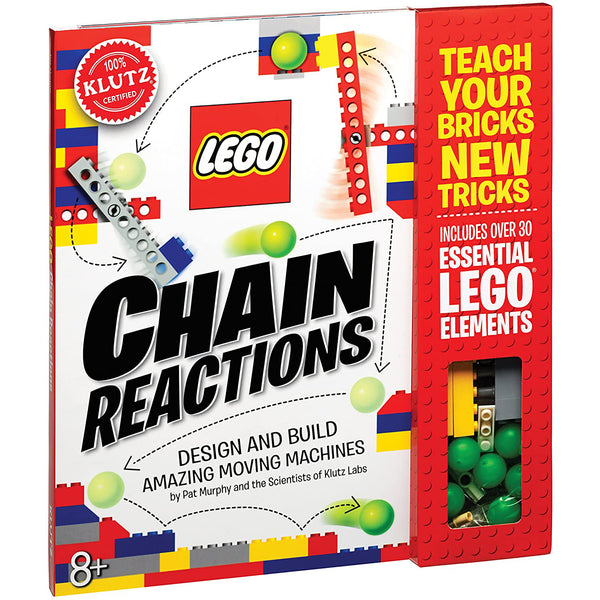Considering the visible LEGO elements through the cut-out window on the cover, what types of simple machines can potentially be built with them, and how might they demonstrate fundamental principles of physics? The visible LEGO elements displayed through the cut-out window, including gears, balls, and various connecting pieces, enable the construction of several types of simple machines such as levers, pulleys, and inclined planes. These components are ideal for demonstrating core physics concepts. For instance, using gears, one can set up a system illustrating the transmission of rotational motion and the effects of gear ratios on speed and torque, offering a vivid demonstration of energy conservation and the principles of force multiplication. Additionally, assembling a lever using these elements could show the principle of leverage, where one can learn about the balance points and the idea of mechanical advantage by moving different weights with varying lever lengths. These practical demonstrations not only engage but deepen the understanding of how forces work in everyday mechanics. 